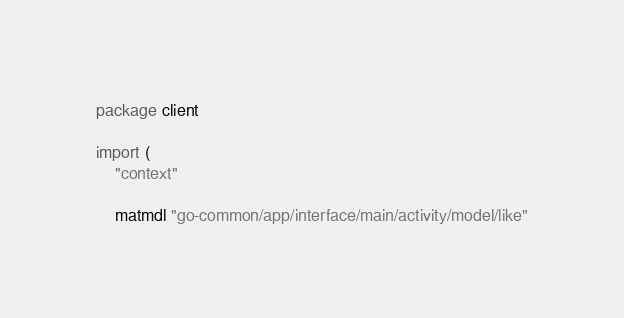Convert code to text. <code><loc_0><loc_0><loc_500><loc_500><_Go_>package client

import (
	"context"

	matmdl "go-common/app/interface/main/activity/model/like"</code> 